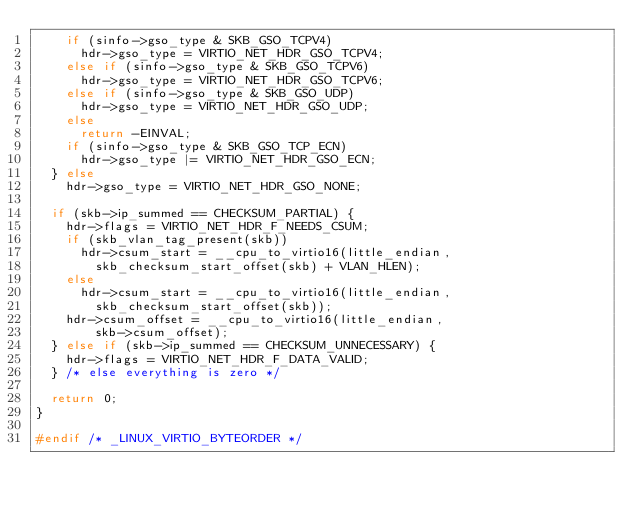<code> <loc_0><loc_0><loc_500><loc_500><_C_>		if (sinfo->gso_type & SKB_GSO_TCPV4)
			hdr->gso_type = VIRTIO_NET_HDR_GSO_TCPV4;
		else if (sinfo->gso_type & SKB_GSO_TCPV6)
			hdr->gso_type = VIRTIO_NET_HDR_GSO_TCPV6;
		else if (sinfo->gso_type & SKB_GSO_UDP)
			hdr->gso_type = VIRTIO_NET_HDR_GSO_UDP;
		else
			return -EINVAL;
		if (sinfo->gso_type & SKB_GSO_TCP_ECN)
			hdr->gso_type |= VIRTIO_NET_HDR_GSO_ECN;
	} else
		hdr->gso_type = VIRTIO_NET_HDR_GSO_NONE;

	if (skb->ip_summed == CHECKSUM_PARTIAL) {
		hdr->flags = VIRTIO_NET_HDR_F_NEEDS_CSUM;
		if (skb_vlan_tag_present(skb))
			hdr->csum_start = __cpu_to_virtio16(little_endian,
				skb_checksum_start_offset(skb) + VLAN_HLEN);
		else
			hdr->csum_start = __cpu_to_virtio16(little_endian,
				skb_checksum_start_offset(skb));
		hdr->csum_offset = __cpu_to_virtio16(little_endian,
				skb->csum_offset);
	} else if (skb->ip_summed == CHECKSUM_UNNECESSARY) {
		hdr->flags = VIRTIO_NET_HDR_F_DATA_VALID;
	} /* else everything is zero */

	return 0;
}

#endif /* _LINUX_VIRTIO_BYTEORDER */
</code> 